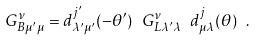<formula> <loc_0><loc_0><loc_500><loc_500>G ^ { \nu } _ { B \mu ^ { \prime } \mu } = d ^ { j ^ { \prime } } _ { \lambda ^ { \prime } \mu ^ { \prime } } ( - \theta ^ { \prime } ) \ G ^ { \nu } _ { L \lambda ^ { \prime } \lambda } \ d ^ { j } _ { \mu \lambda } ( \theta ) \ .</formula> 